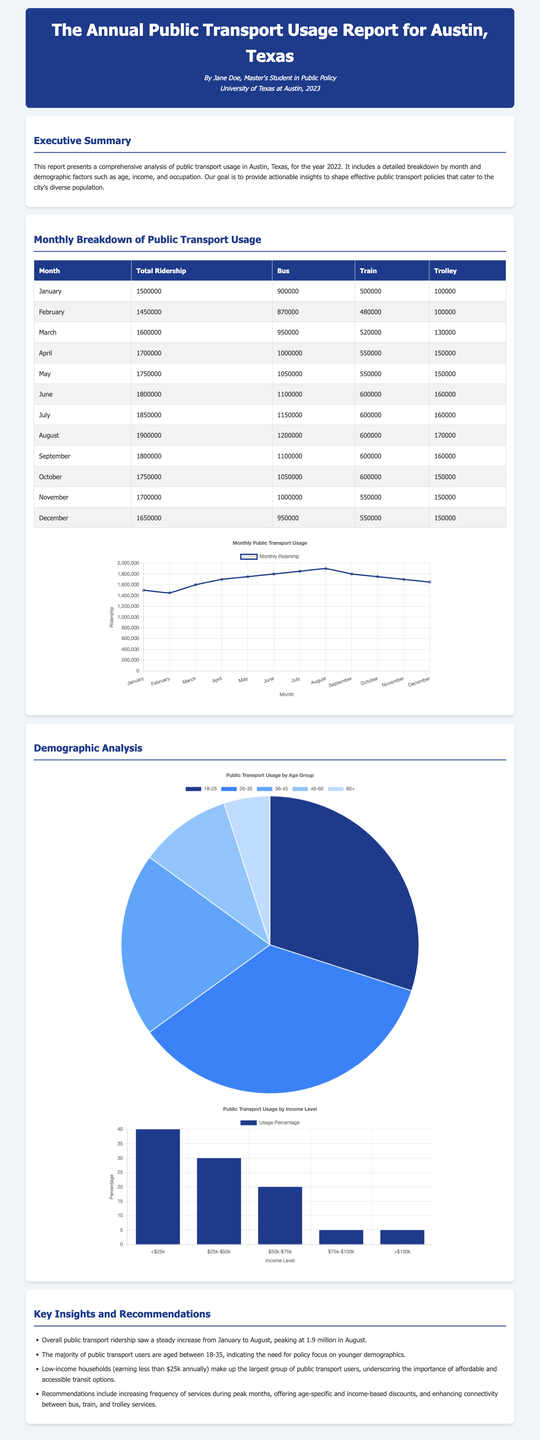What was the total ridership in August? The total ridership for August is specified in the monthly breakdown table as 1,900,000.
Answer: 1,900,000 Which demographic group represents the largest percentage of public transport users? The demographic analysis indicates that low-income households making less than $25,000 annually make up the largest group of public transport users.
Answer: Low-income households What is the highest total ridership recorded in the document? According to the monthly breakdown, the highest total ridership recorded was in August with 1,900,000 passengers.
Answer: 1,900,000 What is the age group with the highest percentage of public transport users? The demographic analysis shows that the age group 26-35 has the highest percentage of users at 35%.
Answer: 26-35 Which month had the lowest total bus ridership? Referring to the monthly breakdown table, January shows the lowest bus ridership with 900,000.
Answer: January What specific recommendation is made regarding service frequency? The report recommends increasing the frequency of services during peak months.
Answer: Increasing frequency during peak months What percentage of public transport users are aged 60 and above? The demographic analysis shows that 5% of public transport users are aged 60 and above.
Answer: 5% Which mode of transport had the highest ridership in June? The monthly breakdown indicates that the bus had the highest ridership in June, totaling 1,100,000 passengers.
Answer: Bus 